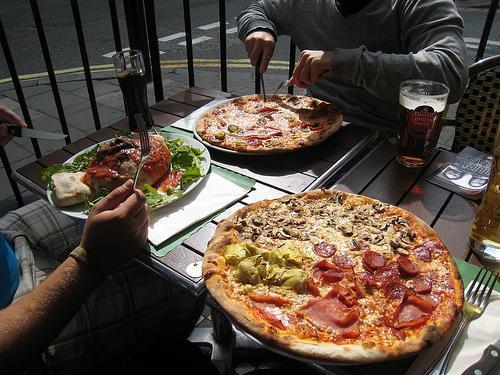How many pizzas are there?
Give a very brief answer. 2. How many men are drinking milk?
Give a very brief answer. 1. 